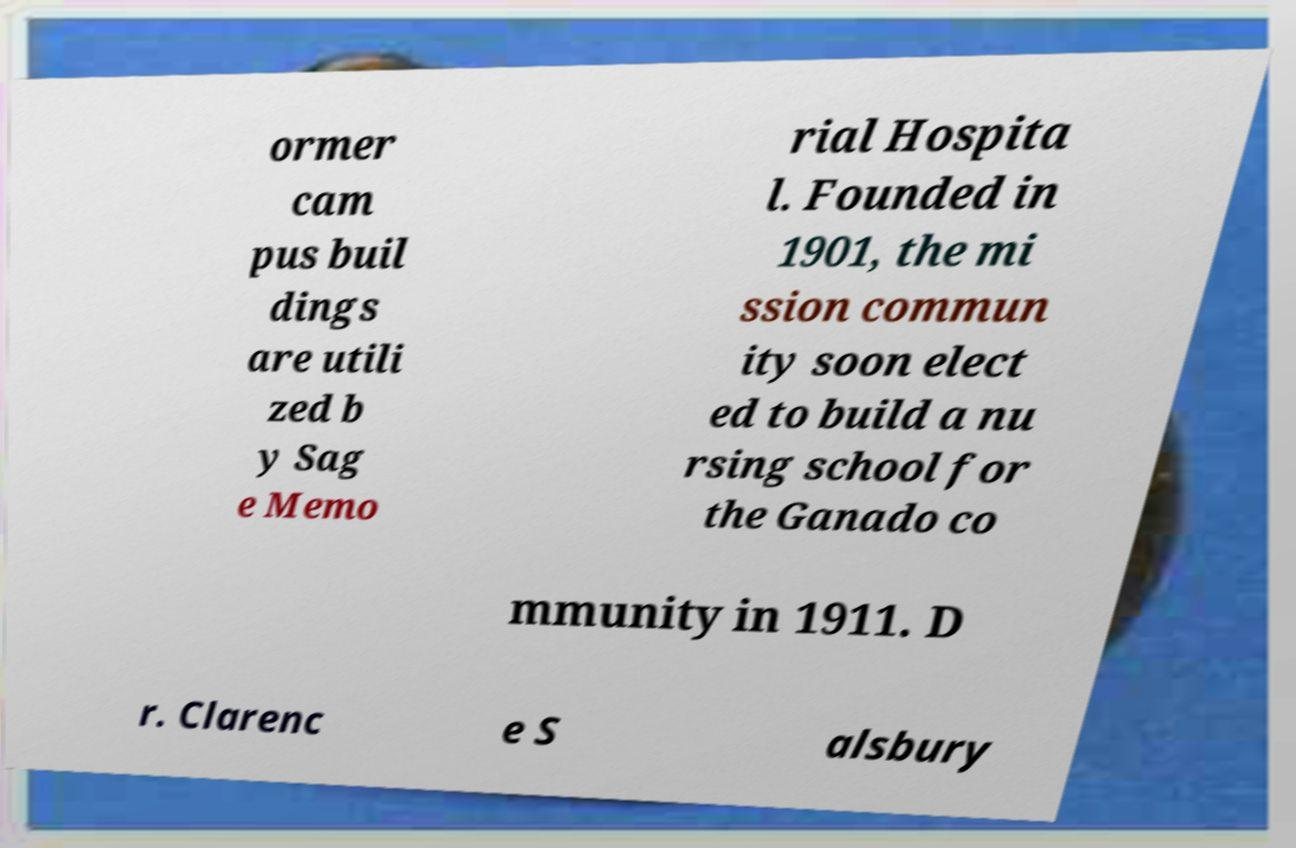Can you accurately transcribe the text from the provided image for me? ormer cam pus buil dings are utili zed b y Sag e Memo rial Hospita l. Founded in 1901, the mi ssion commun ity soon elect ed to build a nu rsing school for the Ganado co mmunity in 1911. D r. Clarenc e S alsbury 